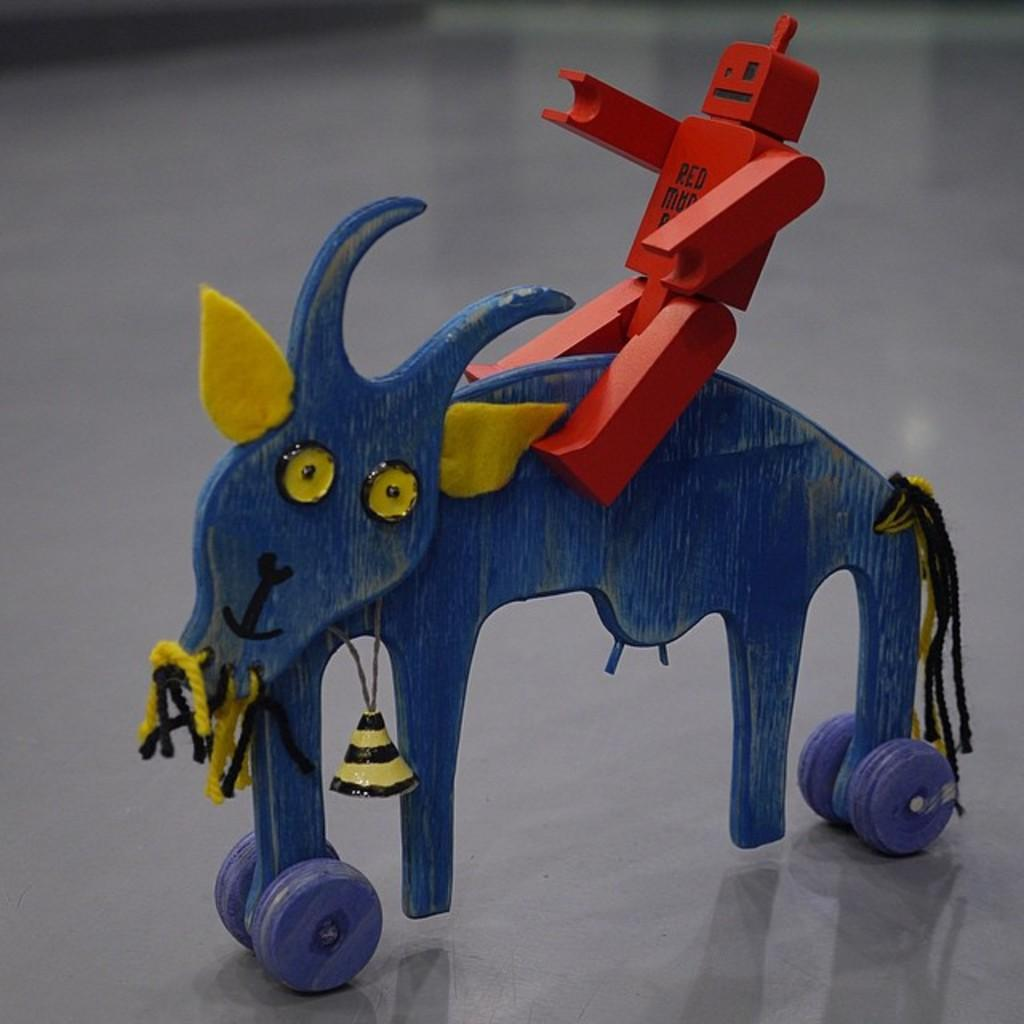What object in the image can be considered a toy? There is a toy in the image. What type of cheese is being used to create a boundary around the toy in the image? There is no cheese or boundary present in the image; it only features a toy. How many kisses can be seen on the toy in the image? There are no kisses visible on the toy in the image. 